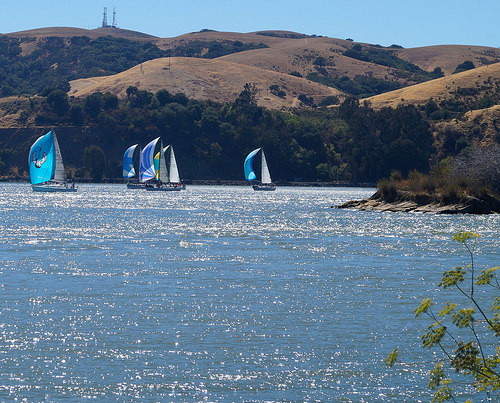<image>
Is there a sailboat on the water? Yes. Looking at the image, I can see the sailboat is positioned on top of the water, with the water providing support. Where is the boat in relation to the plant? Is it in front of the plant? No. The boat is not in front of the plant. The spatial positioning shows a different relationship between these objects. 